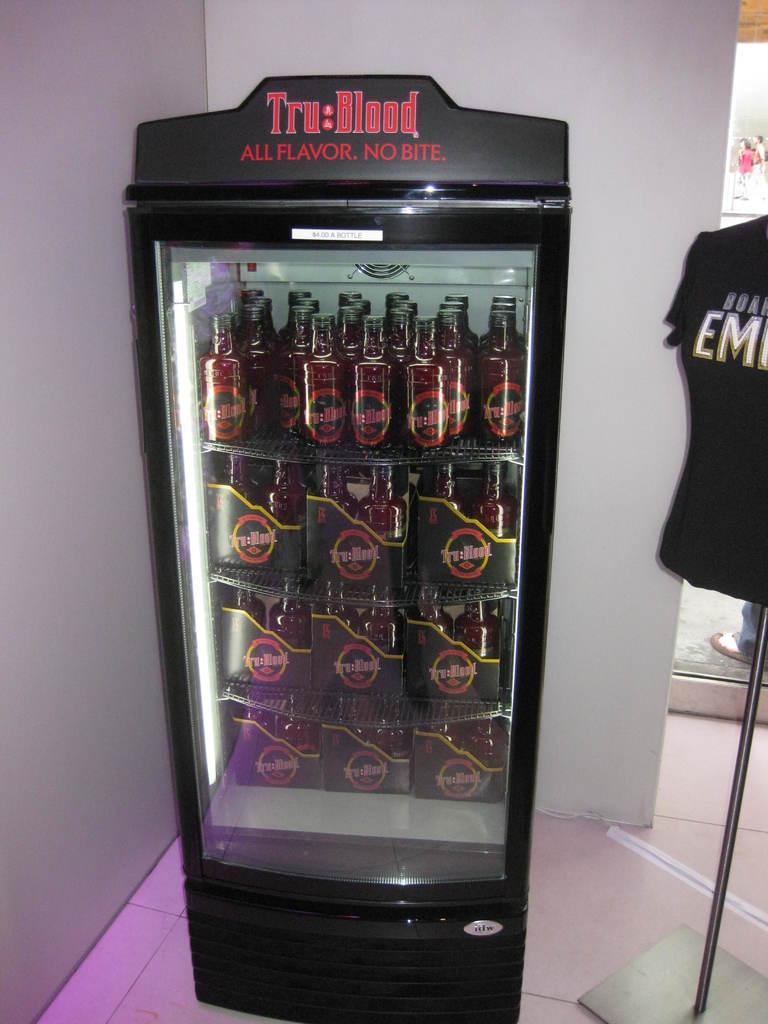What is tru blood's slogan?
Make the answer very short. All flavor. no bite. What brand of drink is in this refrigerator?
Your answer should be very brief. Tru blood. 